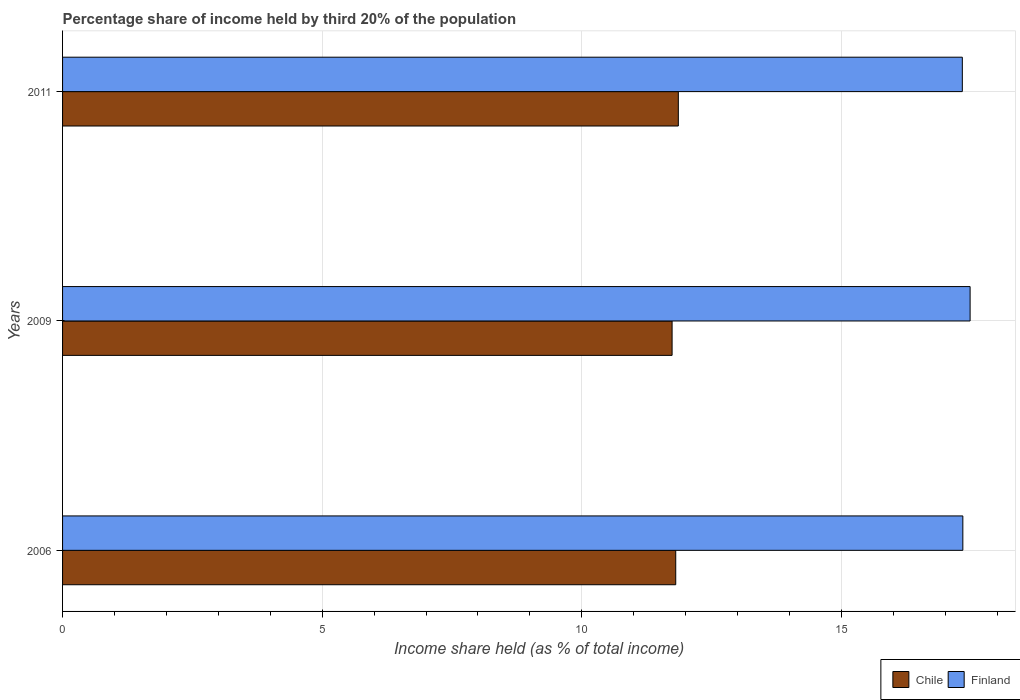How many different coloured bars are there?
Your answer should be compact. 2. How many groups of bars are there?
Your answer should be very brief. 3. Are the number of bars per tick equal to the number of legend labels?
Keep it short and to the point. Yes. Are the number of bars on each tick of the Y-axis equal?
Offer a terse response. Yes. How many bars are there on the 2nd tick from the top?
Your response must be concise. 2. What is the label of the 2nd group of bars from the top?
Keep it short and to the point. 2009. In how many cases, is the number of bars for a given year not equal to the number of legend labels?
Make the answer very short. 0. What is the share of income held by third 20% of the population in Chile in 2006?
Make the answer very short. 11.81. Across all years, what is the maximum share of income held by third 20% of the population in Chile?
Your answer should be very brief. 11.86. Across all years, what is the minimum share of income held by third 20% of the population in Chile?
Keep it short and to the point. 11.74. In which year was the share of income held by third 20% of the population in Chile maximum?
Provide a succinct answer. 2011. What is the total share of income held by third 20% of the population in Finland in the graph?
Your answer should be very brief. 52.15. What is the difference between the share of income held by third 20% of the population in Finland in 2009 and that in 2011?
Offer a very short reply. 0.15. What is the difference between the share of income held by third 20% of the population in Chile in 2009 and the share of income held by third 20% of the population in Finland in 2011?
Your answer should be compact. -5.59. What is the average share of income held by third 20% of the population in Chile per year?
Ensure brevity in your answer.  11.8. In the year 2009, what is the difference between the share of income held by third 20% of the population in Finland and share of income held by third 20% of the population in Chile?
Your answer should be compact. 5.74. In how many years, is the share of income held by third 20% of the population in Chile greater than 7 %?
Make the answer very short. 3. What is the ratio of the share of income held by third 20% of the population in Chile in 2006 to that in 2011?
Provide a short and direct response. 1. Is the share of income held by third 20% of the population in Chile in 2009 less than that in 2011?
Give a very brief answer. Yes. What is the difference between the highest and the second highest share of income held by third 20% of the population in Finland?
Provide a succinct answer. 0.14. What is the difference between the highest and the lowest share of income held by third 20% of the population in Finland?
Your answer should be very brief. 0.15. What does the 2nd bar from the top in 2006 represents?
Make the answer very short. Chile. What does the 2nd bar from the bottom in 2011 represents?
Keep it short and to the point. Finland. How many years are there in the graph?
Provide a short and direct response. 3. What is the difference between two consecutive major ticks on the X-axis?
Give a very brief answer. 5. Does the graph contain grids?
Offer a terse response. Yes. How many legend labels are there?
Offer a terse response. 2. How are the legend labels stacked?
Provide a short and direct response. Horizontal. What is the title of the graph?
Offer a very short reply. Percentage share of income held by third 20% of the population. What is the label or title of the X-axis?
Ensure brevity in your answer.  Income share held (as % of total income). What is the label or title of the Y-axis?
Ensure brevity in your answer.  Years. What is the Income share held (as % of total income) of Chile in 2006?
Ensure brevity in your answer.  11.81. What is the Income share held (as % of total income) in Finland in 2006?
Your answer should be compact. 17.34. What is the Income share held (as % of total income) of Chile in 2009?
Your response must be concise. 11.74. What is the Income share held (as % of total income) of Finland in 2009?
Your response must be concise. 17.48. What is the Income share held (as % of total income) in Chile in 2011?
Give a very brief answer. 11.86. What is the Income share held (as % of total income) in Finland in 2011?
Your response must be concise. 17.33. Across all years, what is the maximum Income share held (as % of total income) of Chile?
Offer a very short reply. 11.86. Across all years, what is the maximum Income share held (as % of total income) of Finland?
Provide a short and direct response. 17.48. Across all years, what is the minimum Income share held (as % of total income) in Chile?
Give a very brief answer. 11.74. Across all years, what is the minimum Income share held (as % of total income) in Finland?
Provide a short and direct response. 17.33. What is the total Income share held (as % of total income) in Chile in the graph?
Offer a terse response. 35.41. What is the total Income share held (as % of total income) in Finland in the graph?
Give a very brief answer. 52.15. What is the difference between the Income share held (as % of total income) in Chile in 2006 and that in 2009?
Provide a succinct answer. 0.07. What is the difference between the Income share held (as % of total income) in Finland in 2006 and that in 2009?
Ensure brevity in your answer.  -0.14. What is the difference between the Income share held (as % of total income) of Chile in 2006 and that in 2011?
Keep it short and to the point. -0.05. What is the difference between the Income share held (as % of total income) in Finland in 2006 and that in 2011?
Give a very brief answer. 0.01. What is the difference between the Income share held (as % of total income) of Chile in 2009 and that in 2011?
Ensure brevity in your answer.  -0.12. What is the difference between the Income share held (as % of total income) of Chile in 2006 and the Income share held (as % of total income) of Finland in 2009?
Your response must be concise. -5.67. What is the difference between the Income share held (as % of total income) of Chile in 2006 and the Income share held (as % of total income) of Finland in 2011?
Your answer should be compact. -5.52. What is the difference between the Income share held (as % of total income) in Chile in 2009 and the Income share held (as % of total income) in Finland in 2011?
Your answer should be compact. -5.59. What is the average Income share held (as % of total income) of Chile per year?
Your response must be concise. 11.8. What is the average Income share held (as % of total income) in Finland per year?
Give a very brief answer. 17.38. In the year 2006, what is the difference between the Income share held (as % of total income) in Chile and Income share held (as % of total income) in Finland?
Make the answer very short. -5.53. In the year 2009, what is the difference between the Income share held (as % of total income) in Chile and Income share held (as % of total income) in Finland?
Give a very brief answer. -5.74. In the year 2011, what is the difference between the Income share held (as % of total income) in Chile and Income share held (as % of total income) in Finland?
Offer a very short reply. -5.47. What is the ratio of the Income share held (as % of total income) in Chile in 2006 to that in 2009?
Your answer should be very brief. 1.01. What is the ratio of the Income share held (as % of total income) of Finland in 2006 to that in 2009?
Make the answer very short. 0.99. What is the ratio of the Income share held (as % of total income) of Chile in 2006 to that in 2011?
Your answer should be compact. 1. What is the ratio of the Income share held (as % of total income) in Finland in 2009 to that in 2011?
Offer a terse response. 1.01. What is the difference between the highest and the second highest Income share held (as % of total income) in Chile?
Keep it short and to the point. 0.05. What is the difference between the highest and the second highest Income share held (as % of total income) in Finland?
Your answer should be very brief. 0.14. What is the difference between the highest and the lowest Income share held (as % of total income) in Chile?
Your answer should be compact. 0.12. 